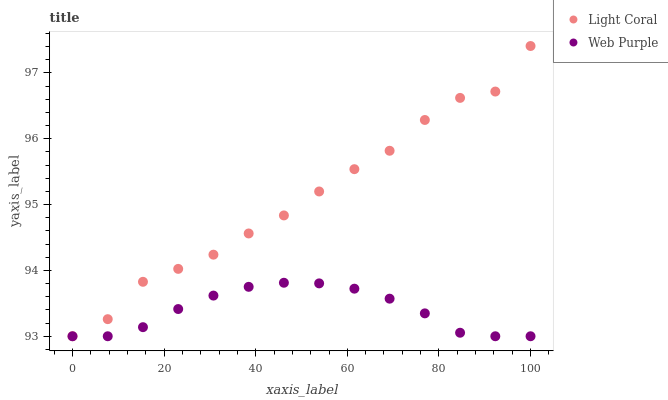Does Web Purple have the minimum area under the curve?
Answer yes or no. Yes. Does Light Coral have the maximum area under the curve?
Answer yes or no. Yes. Does Web Purple have the maximum area under the curve?
Answer yes or no. No. Is Web Purple the smoothest?
Answer yes or no. Yes. Is Light Coral the roughest?
Answer yes or no. Yes. Is Web Purple the roughest?
Answer yes or no. No. Does Light Coral have the lowest value?
Answer yes or no. Yes. Does Light Coral have the highest value?
Answer yes or no. Yes. Does Web Purple have the highest value?
Answer yes or no. No. Does Light Coral intersect Web Purple?
Answer yes or no. Yes. Is Light Coral less than Web Purple?
Answer yes or no. No. Is Light Coral greater than Web Purple?
Answer yes or no. No. 